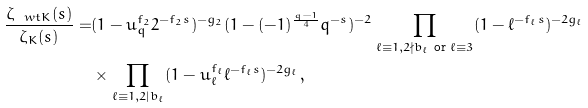Convert formula to latex. <formula><loc_0><loc_0><loc_500><loc_500>\frac { \zeta _ { \ w t K } ( s ) } { \zeta _ { K } ( s ) } = & ( 1 - u _ { q } ^ { f _ { 2 } } 2 ^ { - f _ { 2 } s } ) ^ { - g _ { 2 } } ( 1 - ( - 1 ) ^ { \frac { q - 1 } 4 } q ^ { - s } ) ^ { - 2 } \prod _ { \ell \equiv 1 , 2 \nmid b _ { \ell } \text { or } \ell \equiv 3 } ( 1 - \ell ^ { - f _ { \ell } s } ) ^ { - 2 g _ { \ell } } \\ & \times \prod _ { \ell \equiv 1 , 2 | b _ { \ell } } ( 1 - u _ { \ell } ^ { f _ { \ell } } \ell ^ { - f _ { \ell } s } ) ^ { - 2 g _ { \ell } } ,</formula> 